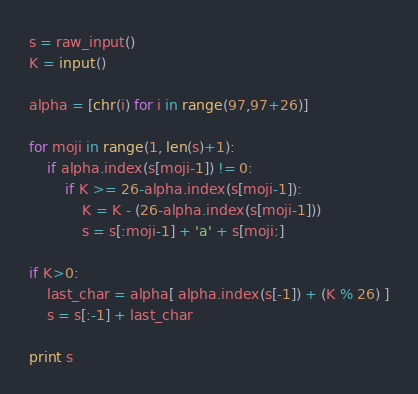<code> <loc_0><loc_0><loc_500><loc_500><_Python_>s = raw_input()
K = input()

alpha = [chr(i) for i in range(97,97+26)]

for moji in range(1, len(s)+1):
	if alpha.index(s[moji-1]) != 0:
		if K >= 26-alpha.index(s[moji-1]):
			K = K - (26-alpha.index(s[moji-1]))
			s = s[:moji-1] + 'a' + s[moji:] 

if K>0:
	last_char = alpha[ alpha.index(s[-1]) + (K % 26) ]
	s = s[:-1] + last_char

print s</code> 